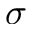Convert formula to latex. <formula><loc_0><loc_0><loc_500><loc_500>\sigma</formula> 